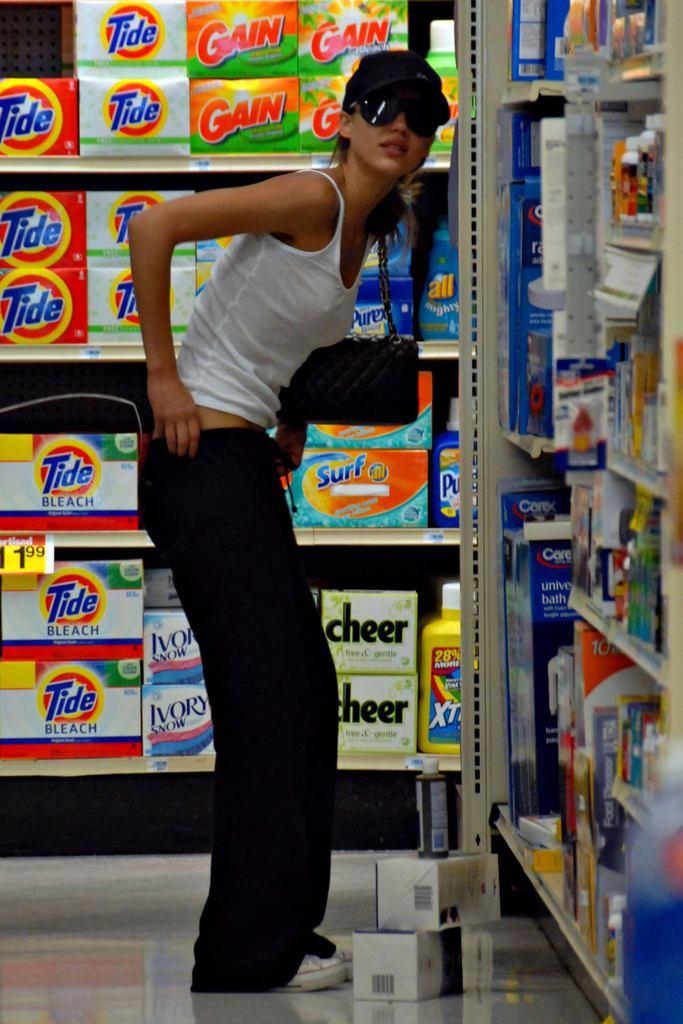How much does tide cost?
Give a very brief answer. 1.99. What type of bleach is behind the girl?
Give a very brief answer. Tide. 